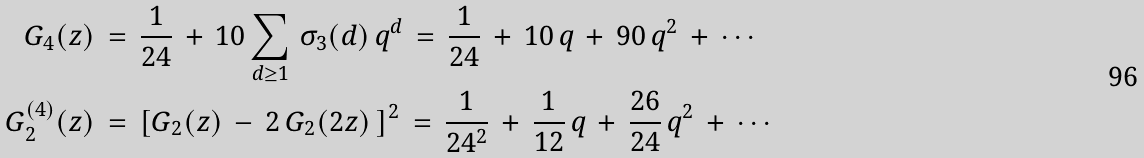Convert formula to latex. <formula><loc_0><loc_0><loc_500><loc_500>G _ { 4 } ( z ) \, & = \, \frac { 1 } { 2 4 } \, + \, 1 0 \sum _ { d \geq 1 } \, \sigma _ { 3 } ( d ) \, q ^ { d } \, = \, \frac { 1 } { 2 4 } \, + \, 1 0 \, q \, + \, 9 0 \, q ^ { 2 } \, + \, \cdots \\ G _ { 2 } ^ { ( 4 ) } ( z ) \, & = \, \left [ G _ { 2 } ( z ) \, - \, 2 \, G _ { 2 } ( 2 z ) \, \right ] ^ { 2 } \, = \, \frac { 1 } { 2 4 ^ { 2 } } \, + \, \frac { 1 } { 1 2 } \, q \, + \, \frac { 2 6 } { 2 4 } \, q ^ { 2 } \, + \, \cdots</formula> 